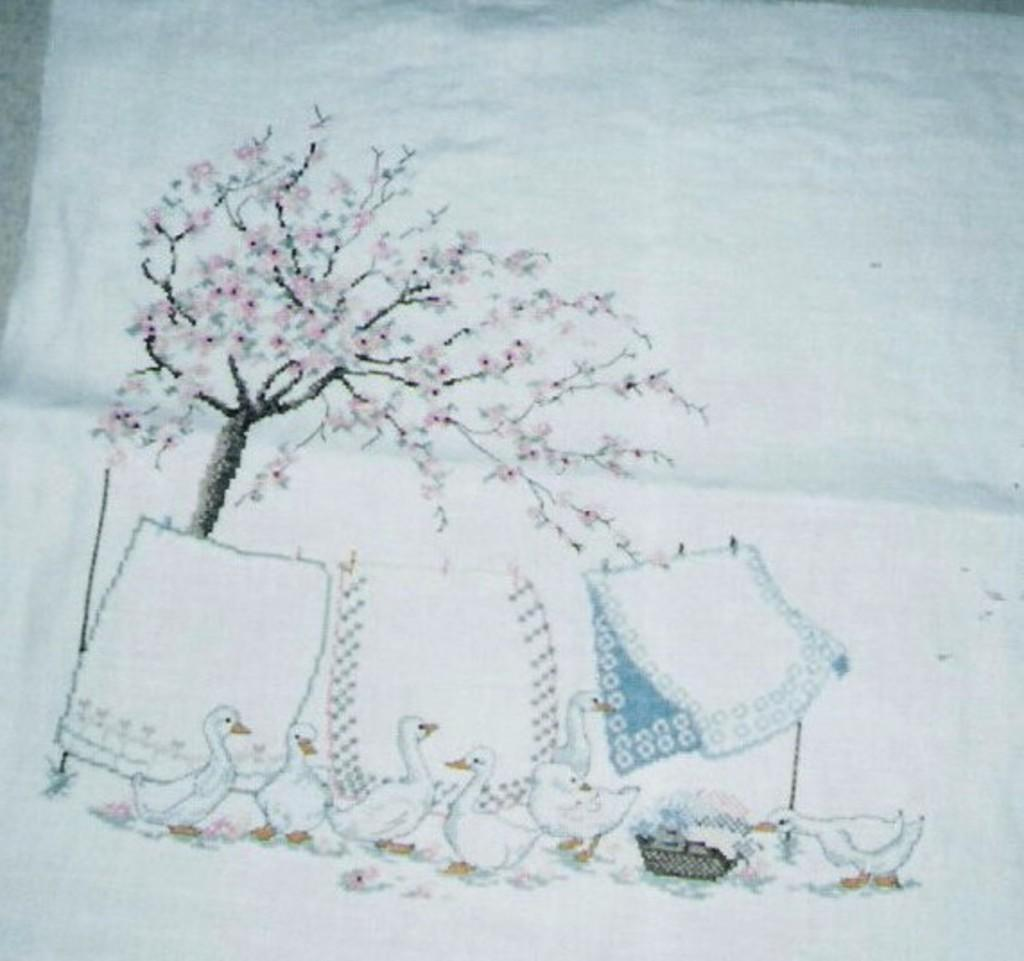What type of decoration can be seen on the cloth in the image? There is embroidery on the cloth in the image. What natural element is present in the image? There is a tree in the image. What type of items are visible in the image? There are clothes and a basket in the image. What animals can be seen in the image? There are ducks in the image. What type of mitten is being used to catch the insect in the image? There is no mitten or insect present in the image. What time of day is depicted in the image? The provided facts do not mention the time of day, so it cannot be determined from the image. 